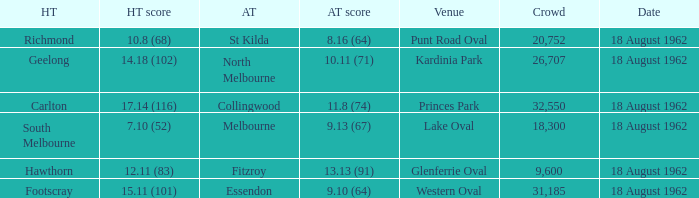What was the away team when the home team scored 10.8 (68)? St Kilda. Help me parse the entirety of this table. {'header': ['HT', 'HT score', 'AT', 'AT score', 'Venue', 'Crowd', 'Date'], 'rows': [['Richmond', '10.8 (68)', 'St Kilda', '8.16 (64)', 'Punt Road Oval', '20,752', '18 August 1962'], ['Geelong', '14.18 (102)', 'North Melbourne', '10.11 (71)', 'Kardinia Park', '26,707', '18 August 1962'], ['Carlton', '17.14 (116)', 'Collingwood', '11.8 (74)', 'Princes Park', '32,550', '18 August 1962'], ['South Melbourne', '7.10 (52)', 'Melbourne', '9.13 (67)', 'Lake Oval', '18,300', '18 August 1962'], ['Hawthorn', '12.11 (83)', 'Fitzroy', '13.13 (91)', 'Glenferrie Oval', '9,600', '18 August 1962'], ['Footscray', '15.11 (101)', 'Essendon', '9.10 (64)', 'Western Oval', '31,185', '18 August 1962']]} 